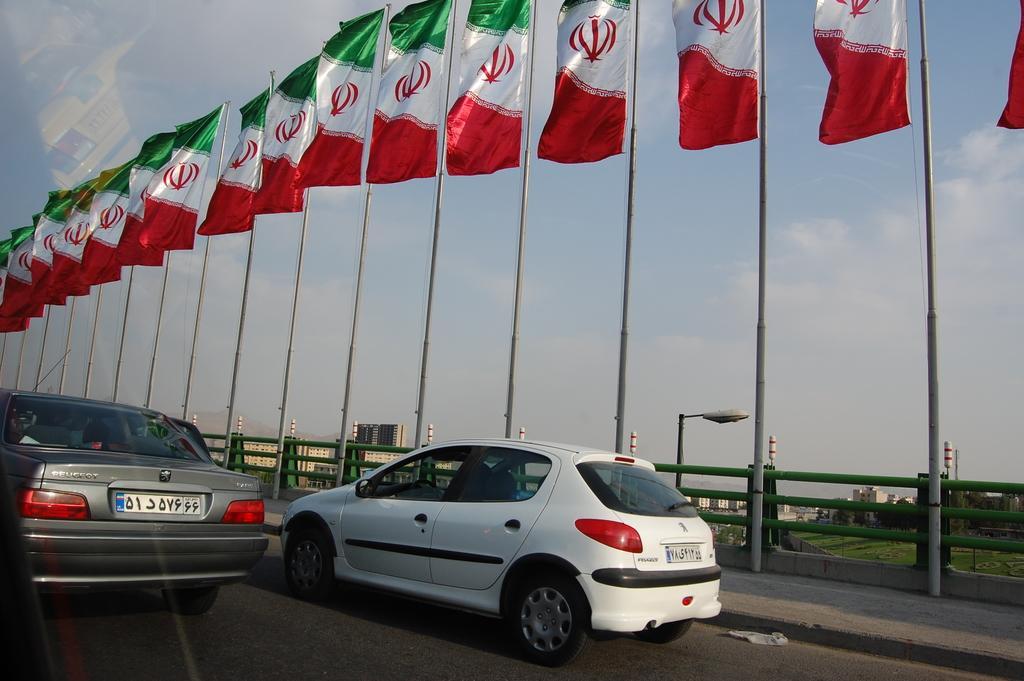Could you give a brief overview of what you see in this image? In this picture we can see vehicles on the road and many flags on the sidewalks. 